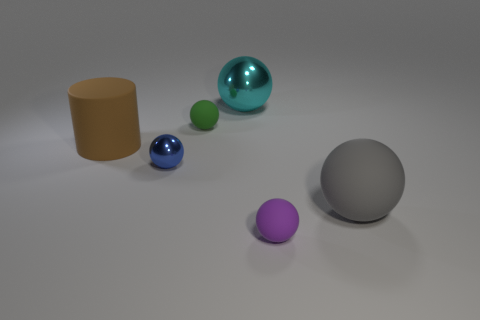Subtract all blue metal spheres. How many spheres are left? 4 Subtract all cylinders. How many objects are left? 5 Add 3 big rubber cylinders. How many objects exist? 9 Subtract all blue spheres. How many spheres are left? 4 Subtract 0 green cylinders. How many objects are left? 6 Subtract 1 cylinders. How many cylinders are left? 0 Subtract all yellow spheres. Subtract all brown cylinders. How many spheres are left? 5 Subtract all yellow blocks. How many purple balls are left? 1 Subtract all big gray things. Subtract all tiny purple matte spheres. How many objects are left? 4 Add 6 rubber objects. How many rubber objects are left? 10 